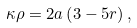<formula> <loc_0><loc_0><loc_500><loc_500>\kappa \rho = 2 a \left ( 3 - 5 r \right ) ,</formula> 